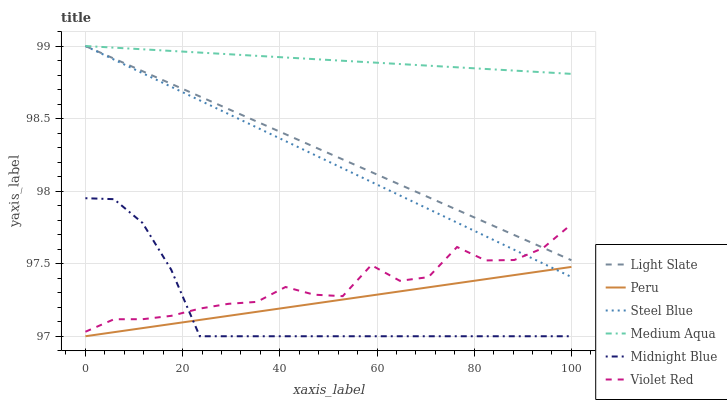Does Midnight Blue have the minimum area under the curve?
Answer yes or no. Yes. Does Medium Aqua have the maximum area under the curve?
Answer yes or no. Yes. Does Light Slate have the minimum area under the curve?
Answer yes or no. No. Does Light Slate have the maximum area under the curve?
Answer yes or no. No. Is Peru the smoothest?
Answer yes or no. Yes. Is Violet Red the roughest?
Answer yes or no. Yes. Is Midnight Blue the smoothest?
Answer yes or no. No. Is Midnight Blue the roughest?
Answer yes or no. No. Does Midnight Blue have the lowest value?
Answer yes or no. Yes. Does Light Slate have the lowest value?
Answer yes or no. No. Does Medium Aqua have the highest value?
Answer yes or no. Yes. Does Midnight Blue have the highest value?
Answer yes or no. No. Is Peru less than Medium Aqua?
Answer yes or no. Yes. Is Light Slate greater than Midnight Blue?
Answer yes or no. Yes. Does Midnight Blue intersect Peru?
Answer yes or no. Yes. Is Midnight Blue less than Peru?
Answer yes or no. No. Is Midnight Blue greater than Peru?
Answer yes or no. No. Does Peru intersect Medium Aqua?
Answer yes or no. No. 